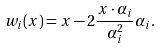<formula> <loc_0><loc_0><loc_500><loc_500>w _ { i } ( x ) = x - 2 \frac { x \cdot \alpha _ { i } } { \alpha _ { i } ^ { 2 } } \alpha _ { i } .</formula> 